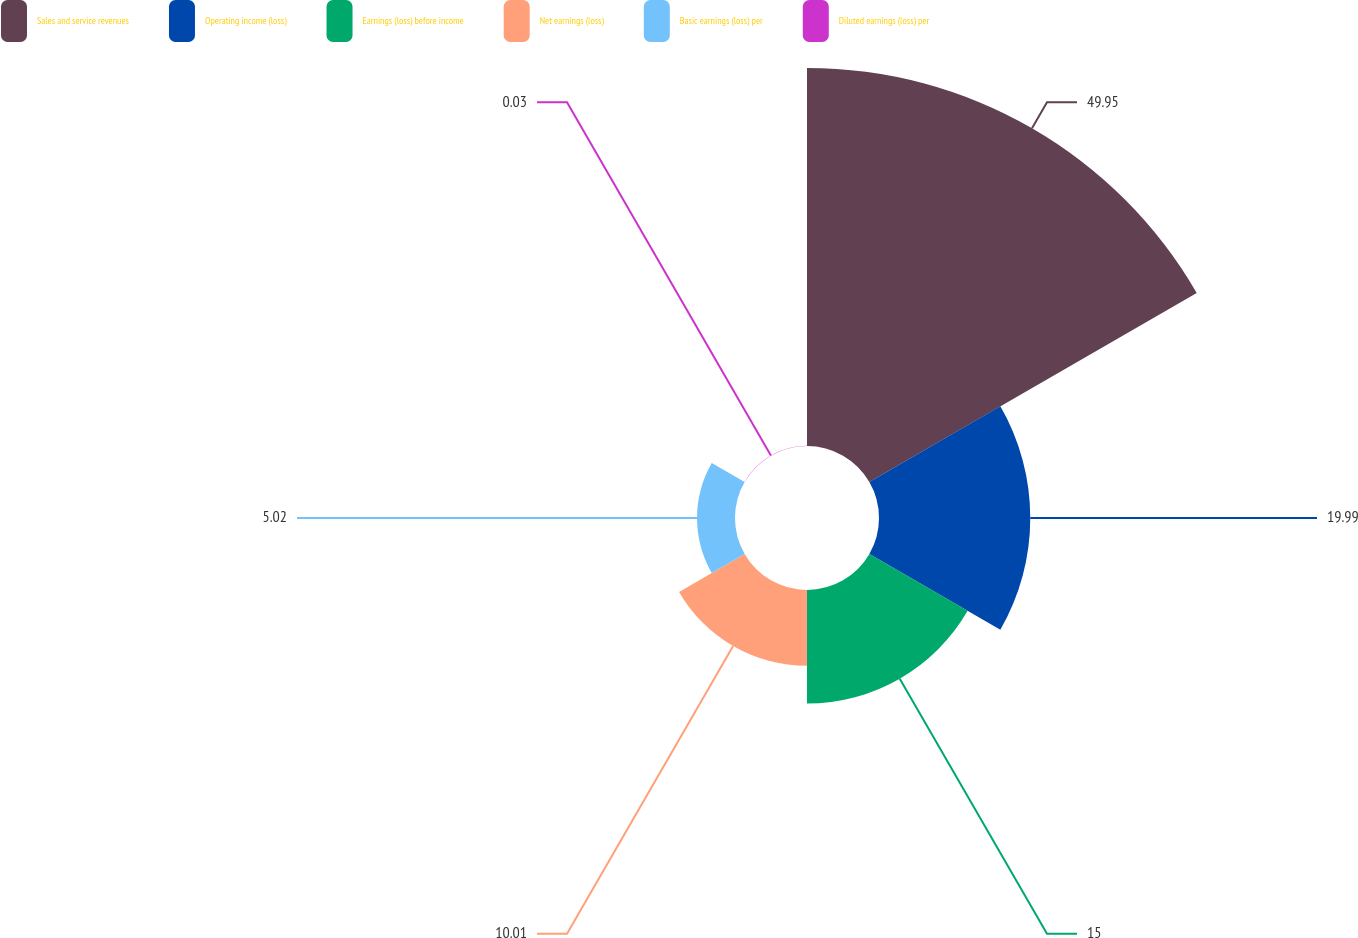<chart> <loc_0><loc_0><loc_500><loc_500><pie_chart><fcel>Sales and service revenues<fcel>Operating income (loss)<fcel>Earnings (loss) before income<fcel>Net earnings (loss)<fcel>Basic earnings (loss) per<fcel>Diluted earnings (loss) per<nl><fcel>49.95%<fcel>19.99%<fcel>15.0%<fcel>10.01%<fcel>5.02%<fcel>0.03%<nl></chart> 